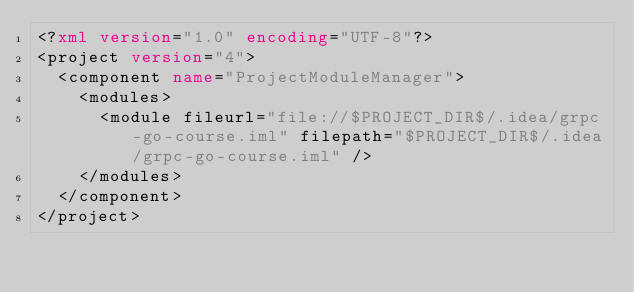Convert code to text. <code><loc_0><loc_0><loc_500><loc_500><_XML_><?xml version="1.0" encoding="UTF-8"?>
<project version="4">
  <component name="ProjectModuleManager">
    <modules>
      <module fileurl="file://$PROJECT_DIR$/.idea/grpc-go-course.iml" filepath="$PROJECT_DIR$/.idea/grpc-go-course.iml" />
    </modules>
  </component>
</project></code> 